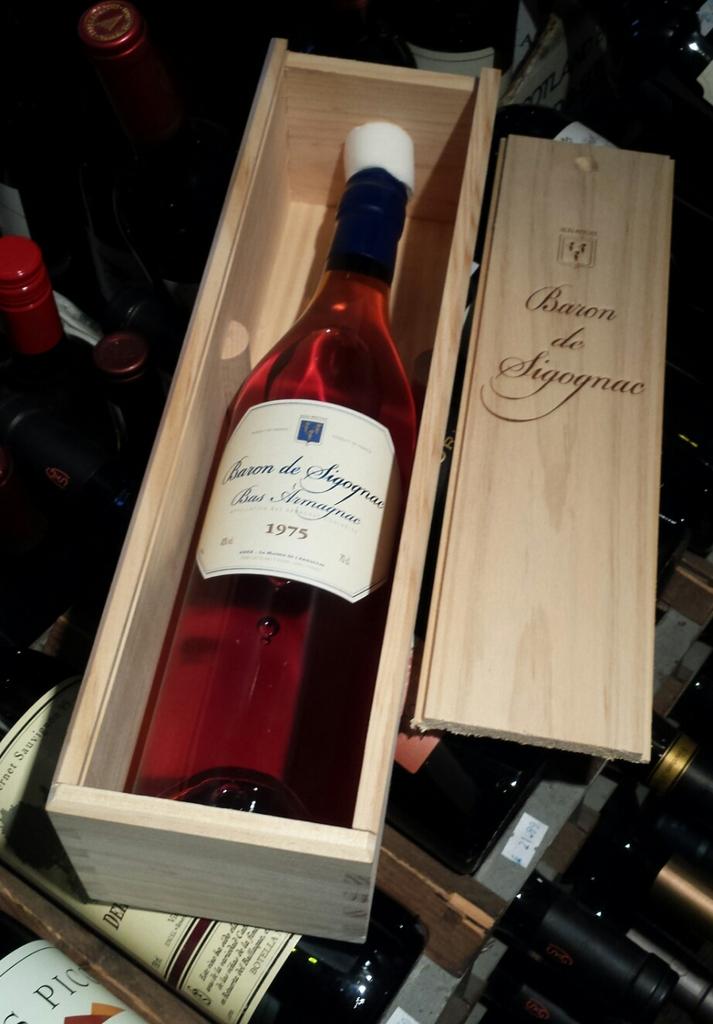What year is this wine?
Provide a succinct answer. 1975. 